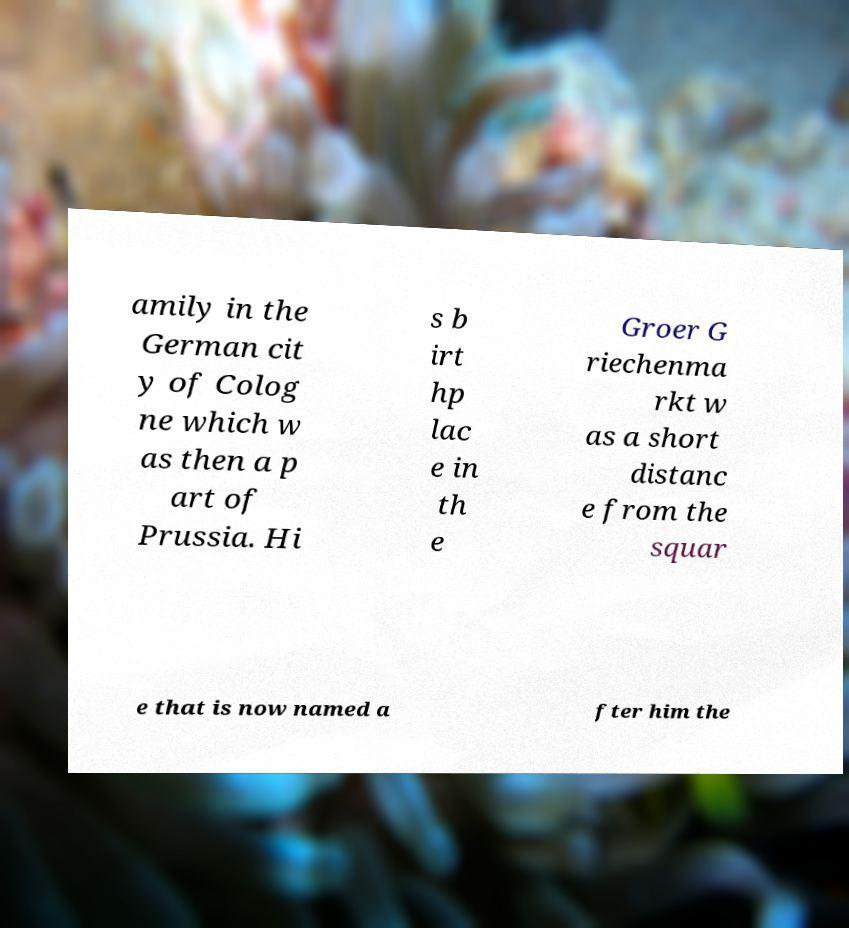Please read and relay the text visible in this image. What does it say? amily in the German cit y of Colog ne which w as then a p art of Prussia. Hi s b irt hp lac e in th e Groer G riechenma rkt w as a short distanc e from the squar e that is now named a fter him the 